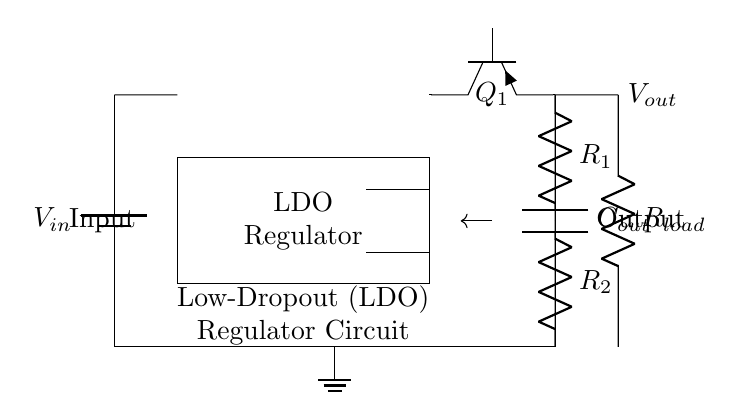What is the input voltage in the circuit? The input voltage is represented by the battery symbol labeled V_{in}, which is connected to the entire circuit at the top.
Answer: V_{in} What type of transistor is used in the regulator? The pass transistor in the circuit is indicated by the symbol Tpnp, which denotes a PNP type transistor responsible for regulating the output voltage.
Answer: PNP What is the total resistance in the feedback network? The feedback network consists of two resistors, R_1 and R_2, connected in series, therefore the total resistance would be the sum of these two resistors. However, without specific values, we can say that the total resistance is R_1 + R_2.
Answer: R_1 + R_2 What is the function of capacitor C_out? Capacitor C_out is directly connected to the output, providing stability and filtering to the output voltage, which helps in smoothing the output and reducing noise.
Answer: Stabilization What type of circuit is this? This circuit operates specifically as a Low-Dropout (LDO) regulator, suitable for providing a stable output voltage even when the input voltage is slightly higher than the desired output voltage.
Answer: LDO Regulator What is connected to the output of the regulator? The output of the LDO regulator connects to a load resistor R_load, which represents the load being powered by the regulated output voltage.
Answer: R_load What determines the LDO's dropout voltage? The dropout voltage is determined by the characteristics of the pass transistor Q_1 and is defined as the minimum difference required between the input voltage and the output voltage for the regulator to maintain regulation.
Answer: Pass transistor characteristics 